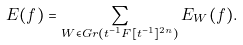Convert formula to latex. <formula><loc_0><loc_0><loc_500><loc_500>E ( f ) = \sum _ { W \in G r ( t ^ { - 1 } F [ t ^ { - 1 } ] ^ { 2 n } ) } E _ { W } ( f ) .</formula> 